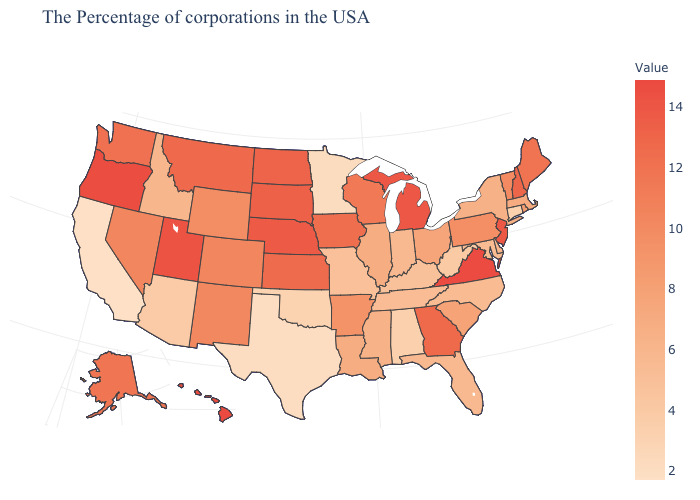Among the states that border Connecticut , does Rhode Island have the highest value?
Answer briefly. Yes. Which states have the highest value in the USA?
Quick response, please. Hawaii. Does Virginia have the highest value in the South?
Write a very short answer. Yes. Which states have the lowest value in the Northeast?
Give a very brief answer. Connecticut. Does Wisconsin have the lowest value in the USA?
Short answer required. No. Does California have the lowest value in the West?
Quick response, please. Yes. Does Montana have the highest value in the West?
Keep it brief. No. 